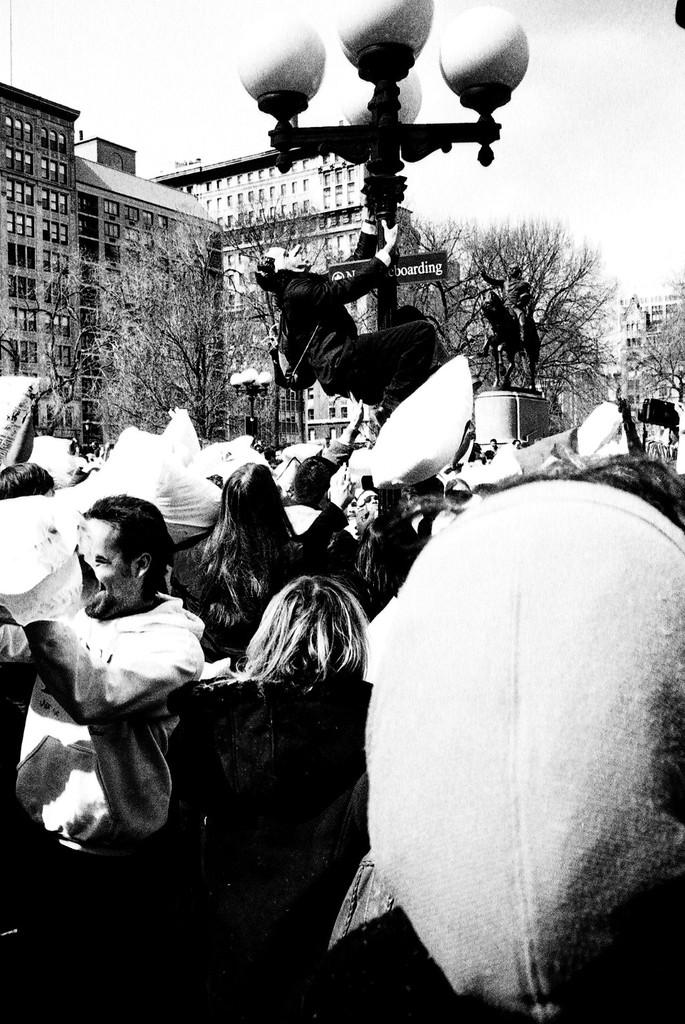What is the color scheme of the image? The image is black and white. Who or what can be seen in the image? There are persons in the image. Can you describe the lighting in the image? There is light visible in the image. What type of natural elements are present in the image? There are trees in the image. What type of man-made structures can be seen in the image? There are buildings in the image. What is visible in the background of the image? The sky is visible in the image. What type of tin can be seen in the image? There is no tin present in the image. How does the nerve affect the persons in the image? There is no mention of a nerve or any medical condition affecting the persons in the image. 